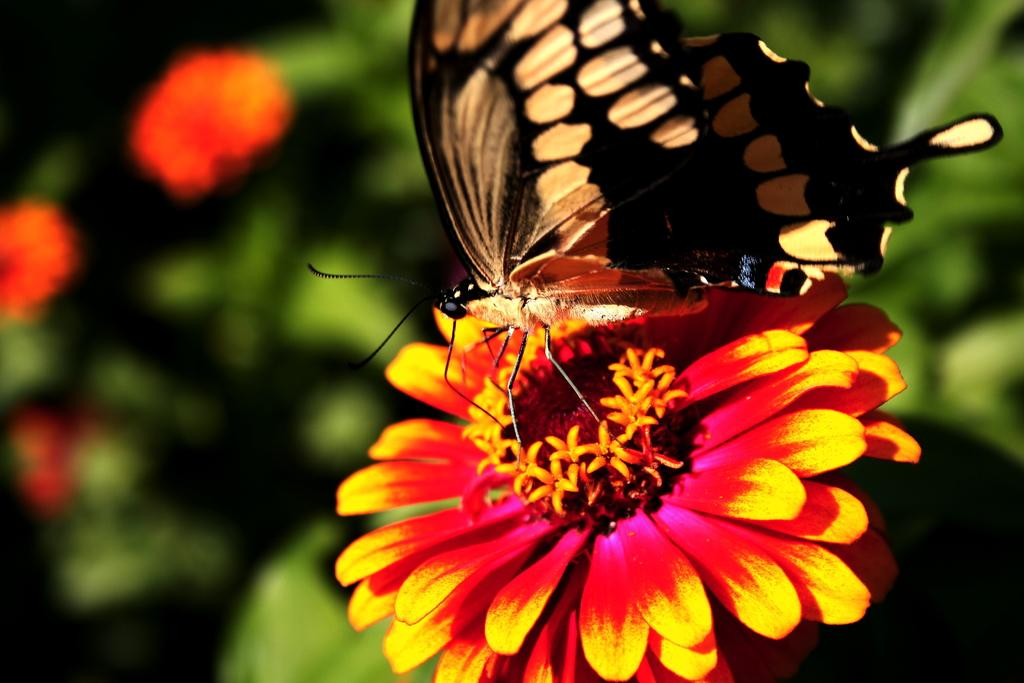What is on the flower in the image? There is a butterfly on a flower in the image. What can be seen in the background of the image? There are flowers and leaves in the background of the image. What type of cast can be seen on the butterfly's hand in the image? There is no cast or hand present on the butterfly in the image. 